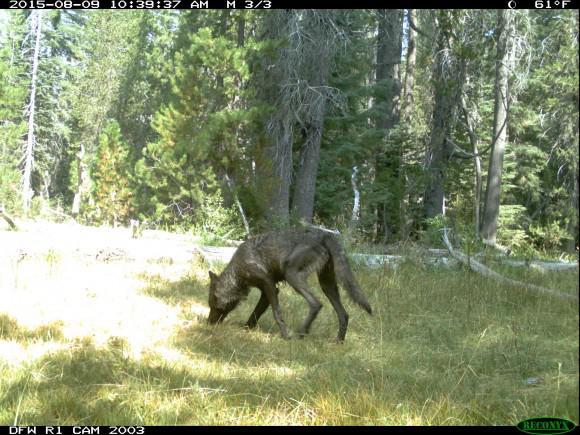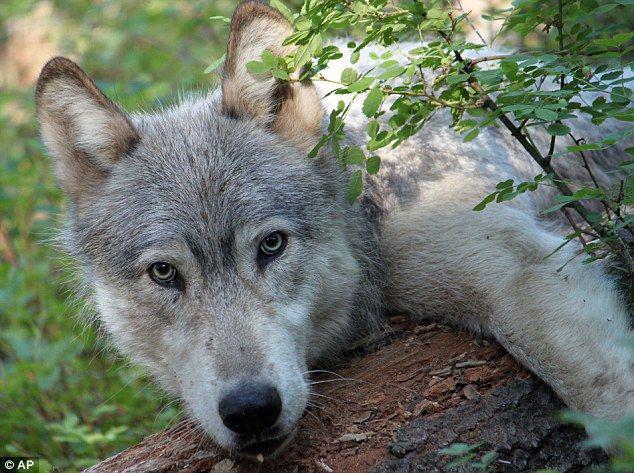The first image is the image on the left, the second image is the image on the right. Assess this claim about the two images: "The right image contains one wolf, a pup standing in front of trees with its body turned rightward.". Correct or not? Answer yes or no. No. The first image is the image on the left, the second image is the image on the right. For the images displayed, is the sentence "There are multiple animals in the wild in the image on the left." factually correct? Answer yes or no. No. 